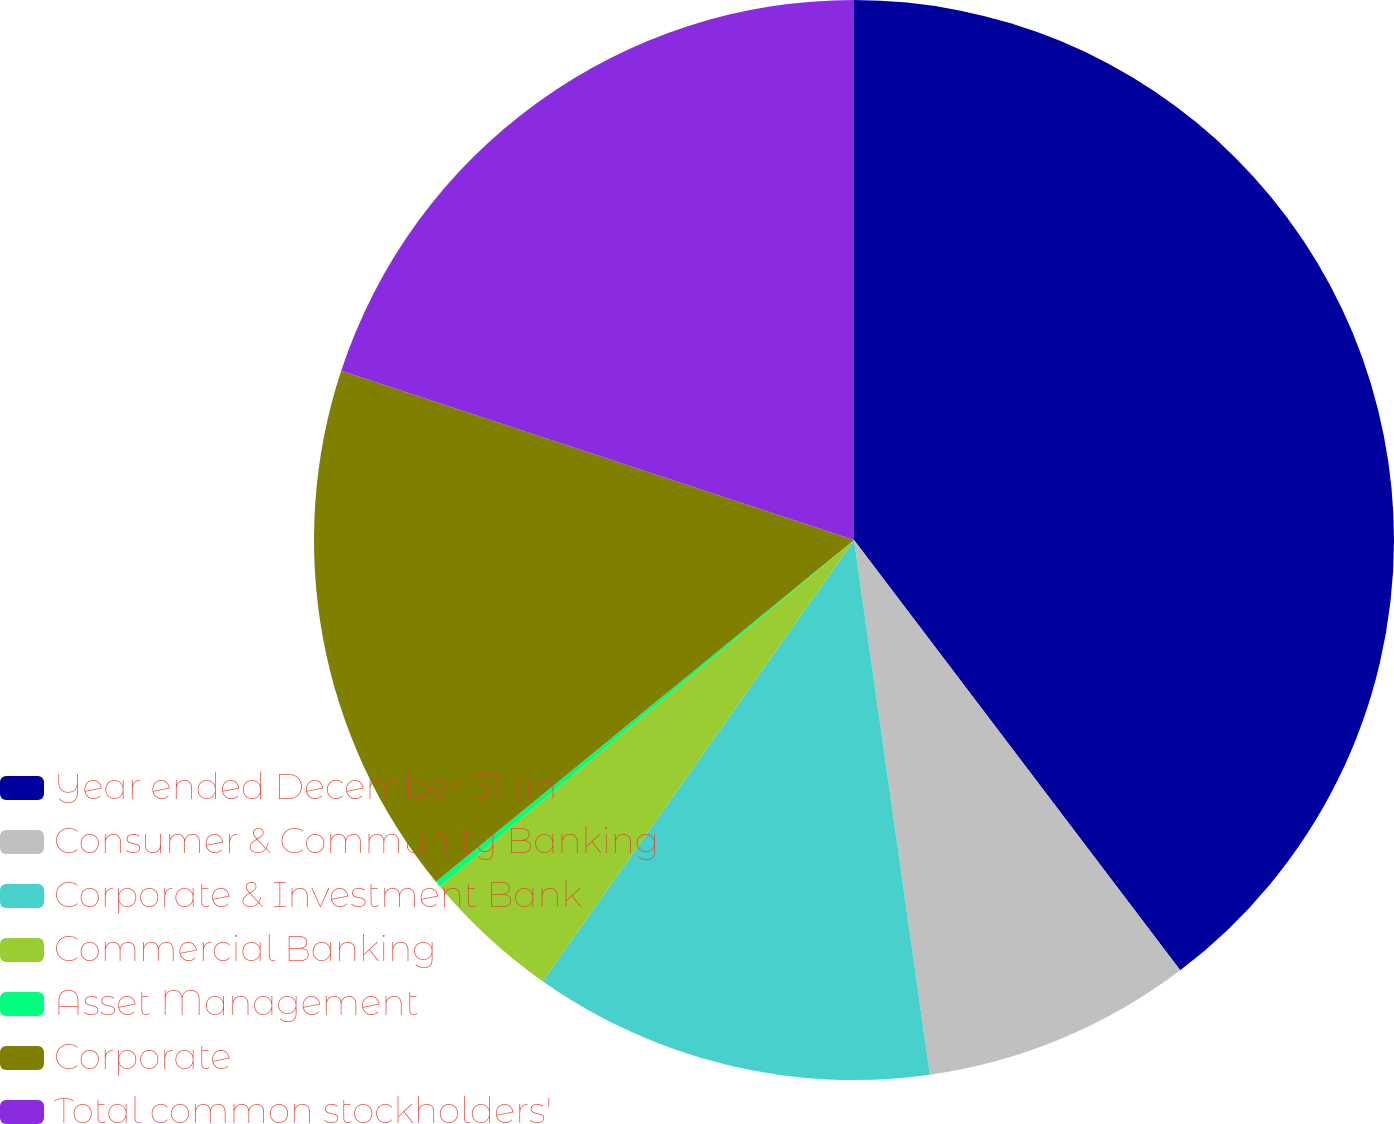Convert chart. <chart><loc_0><loc_0><loc_500><loc_500><pie_chart><fcel>Year ended December 31 (in<fcel>Consumer & Community Banking<fcel>Corporate & Investment Bank<fcel>Commercial Banking<fcel>Asset Management<fcel>Corporate<fcel>Total common stockholders'<nl><fcel>39.68%<fcel>8.08%<fcel>12.03%<fcel>4.13%<fcel>0.18%<fcel>15.98%<fcel>19.93%<nl></chart> 